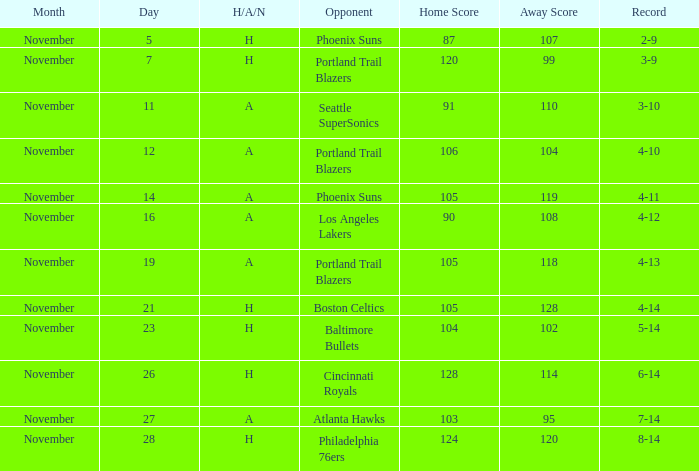I'm looking to parse the entire table for insights. Could you assist me with that? {'header': ['Month', 'Day', 'H/A/N', 'Opponent', 'Home Score', 'Away Score', 'Record'], 'rows': [['November', '5', 'H', 'Phoenix Suns', '87', '107', '2-9'], ['November', '7', 'H', 'Portland Trail Blazers', '120', '99', '3-9'], ['November', '11', 'A', 'Seattle SuperSonics', '91', '110', '3-10'], ['November', '12', 'A', 'Portland Trail Blazers', '106', '104', '4-10'], ['November', '14', 'A', 'Phoenix Suns', '105', '119', '4-11'], ['November', '16', 'A', 'Los Angeles Lakers', '90', '108', '4-12'], ['November', '19', 'A', 'Portland Trail Blazers', '105', '118', '4-13'], ['November', '21', 'H', 'Boston Celtics', '105', '128', '4-14'], ['November', '23', 'H', 'Baltimore Bullets', '104', '102', '5-14'], ['November', '26', 'H', 'Cincinnati Royals', '128', '114', '6-14'], ['November', '27', 'A', 'Atlanta Hawks', '103', '95', '7-14'], ['November', '28', 'H', 'Philadelphia 76ers', '124', '120', '8-14']]} On what Date was the Score 106-104 against the Portland Trail Blazers? November 12. 